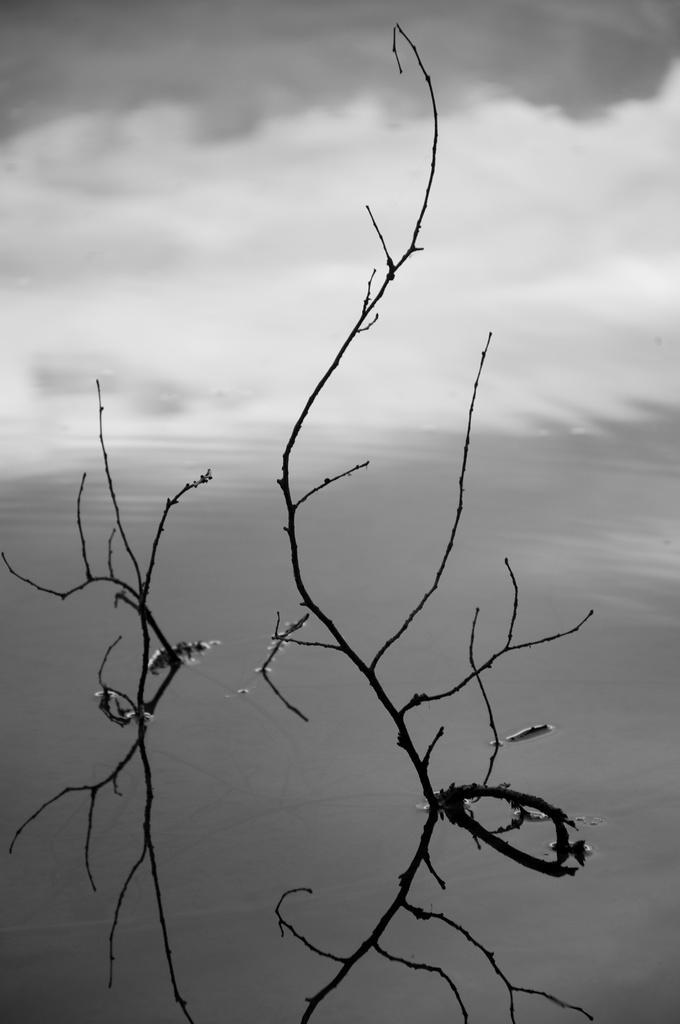Can you describe this image briefly? In the foreground of this image, we can see water body and few stems in the water. On the top, we can see the sky and the cloud. 